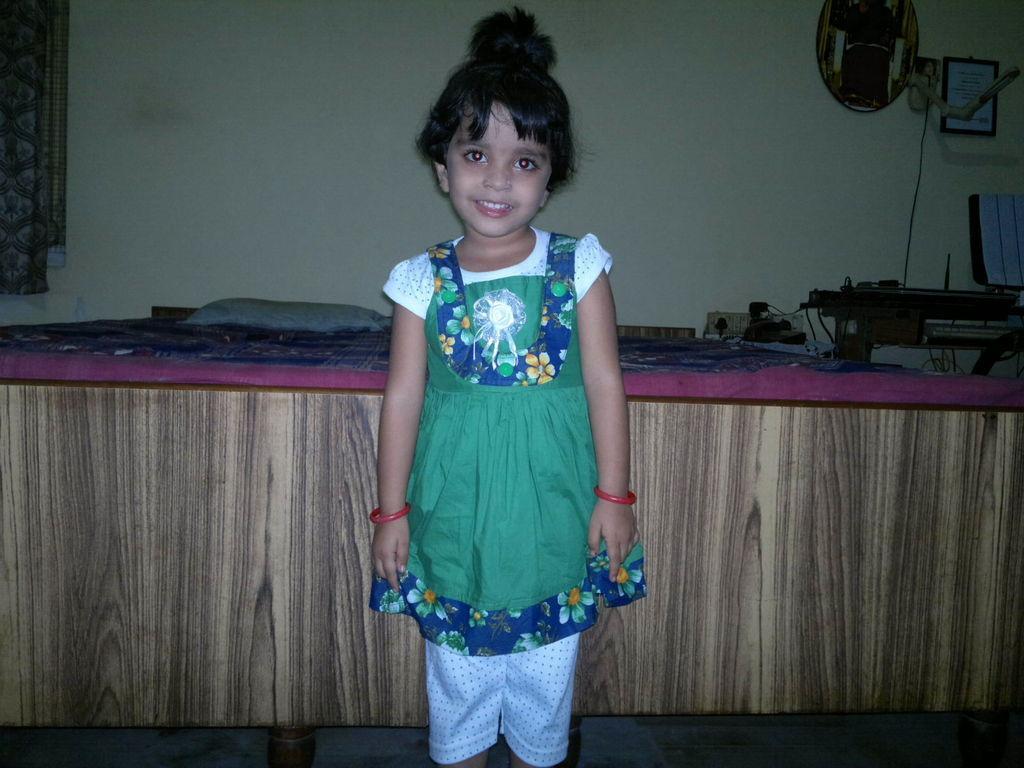How would you summarize this image in a sentence or two? In the image I can see a kid who is standing in front of the bed on which there is a pillow and beside there is a table on which there are some things placed. 